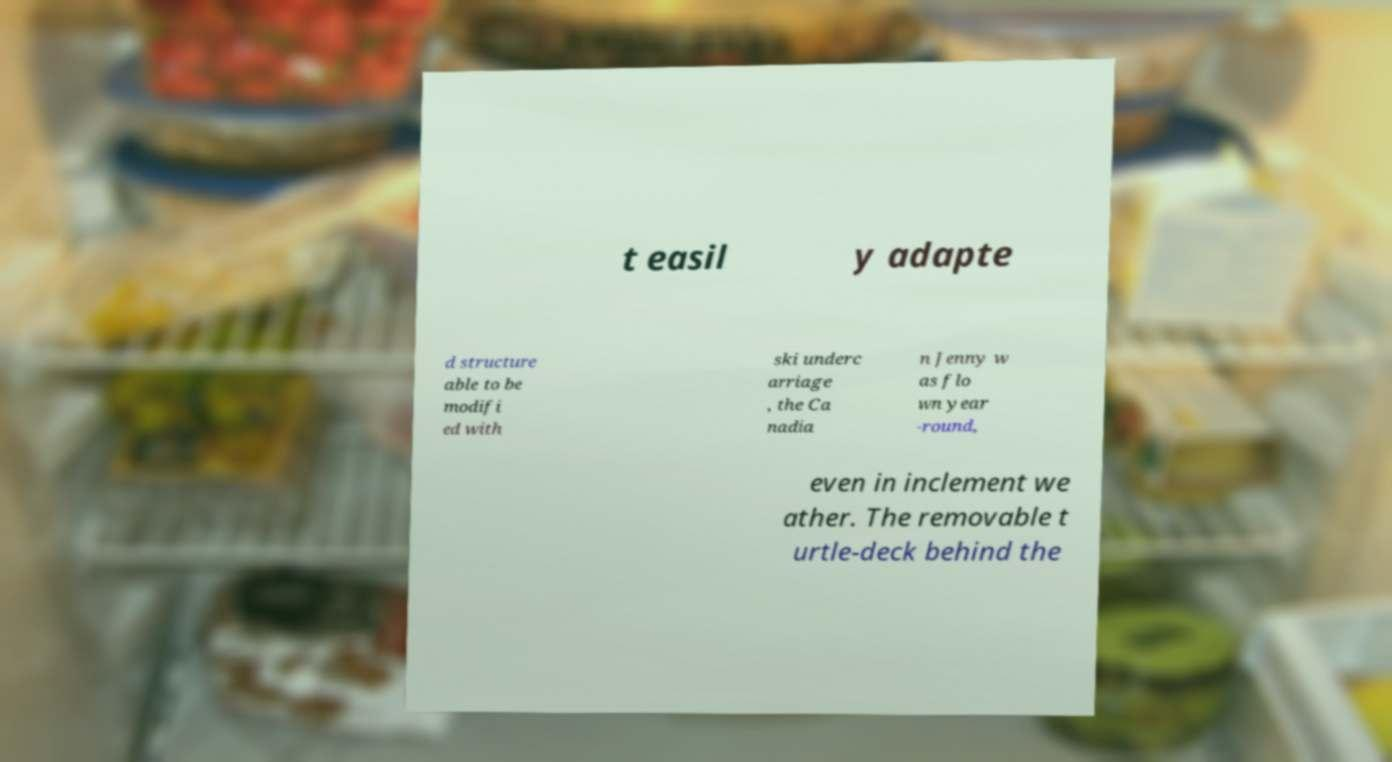Please read and relay the text visible in this image. What does it say? t easil y adapte d structure able to be modifi ed with ski underc arriage , the Ca nadia n Jenny w as flo wn year -round, even in inclement we ather. The removable t urtle-deck behind the 